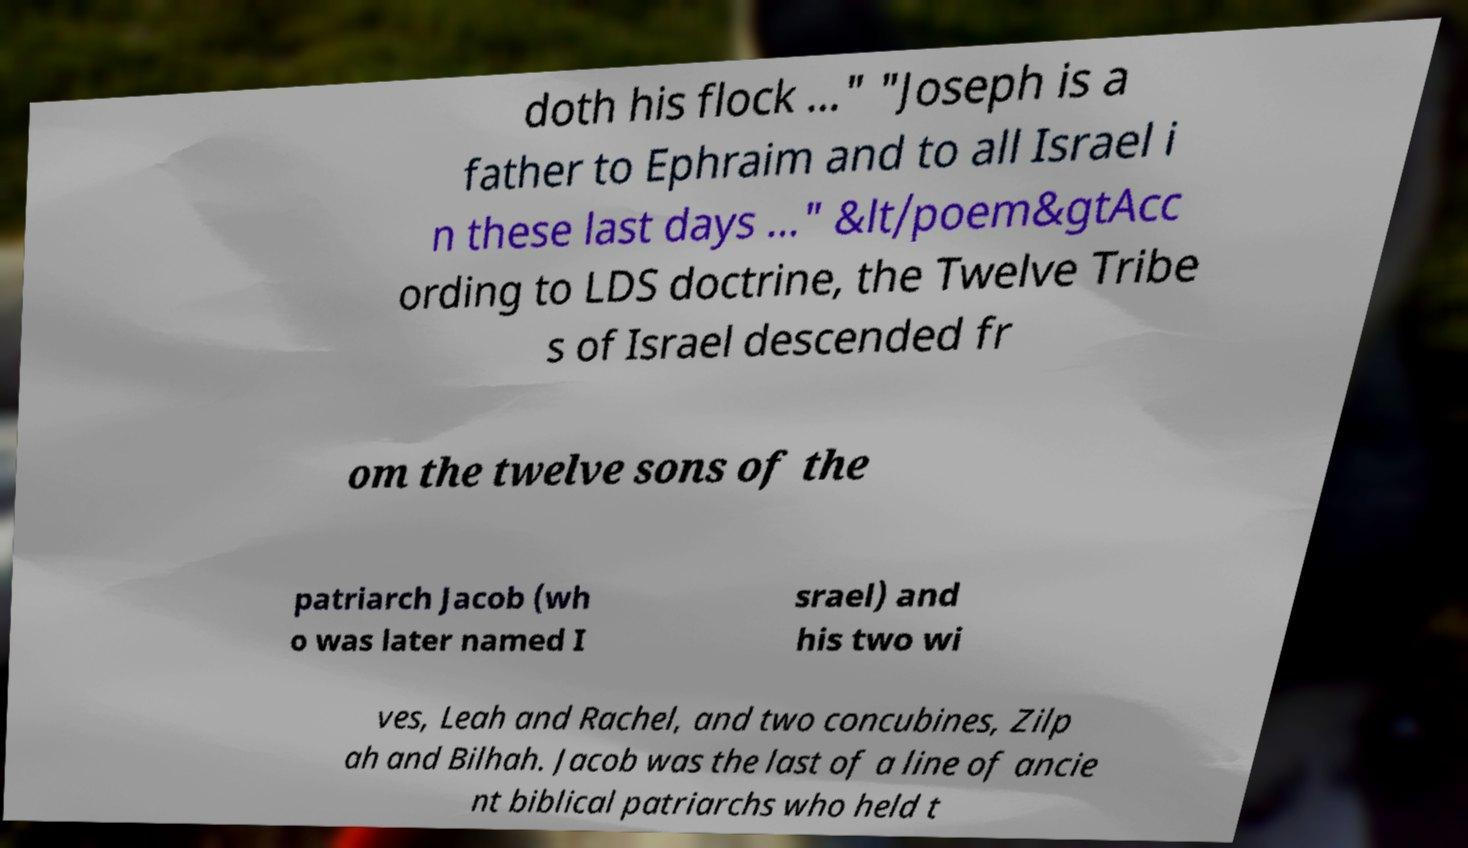For documentation purposes, I need the text within this image transcribed. Could you provide that? doth his flock ..." "Joseph is a father to Ephraim and to all Israel i n these last days ..." &lt/poem&gtAcc ording to LDS doctrine, the Twelve Tribe s of Israel descended fr om the twelve sons of the patriarch Jacob (wh o was later named I srael) and his two wi ves, Leah and Rachel, and two concubines, Zilp ah and Bilhah. Jacob was the last of a line of ancie nt biblical patriarchs who held t 